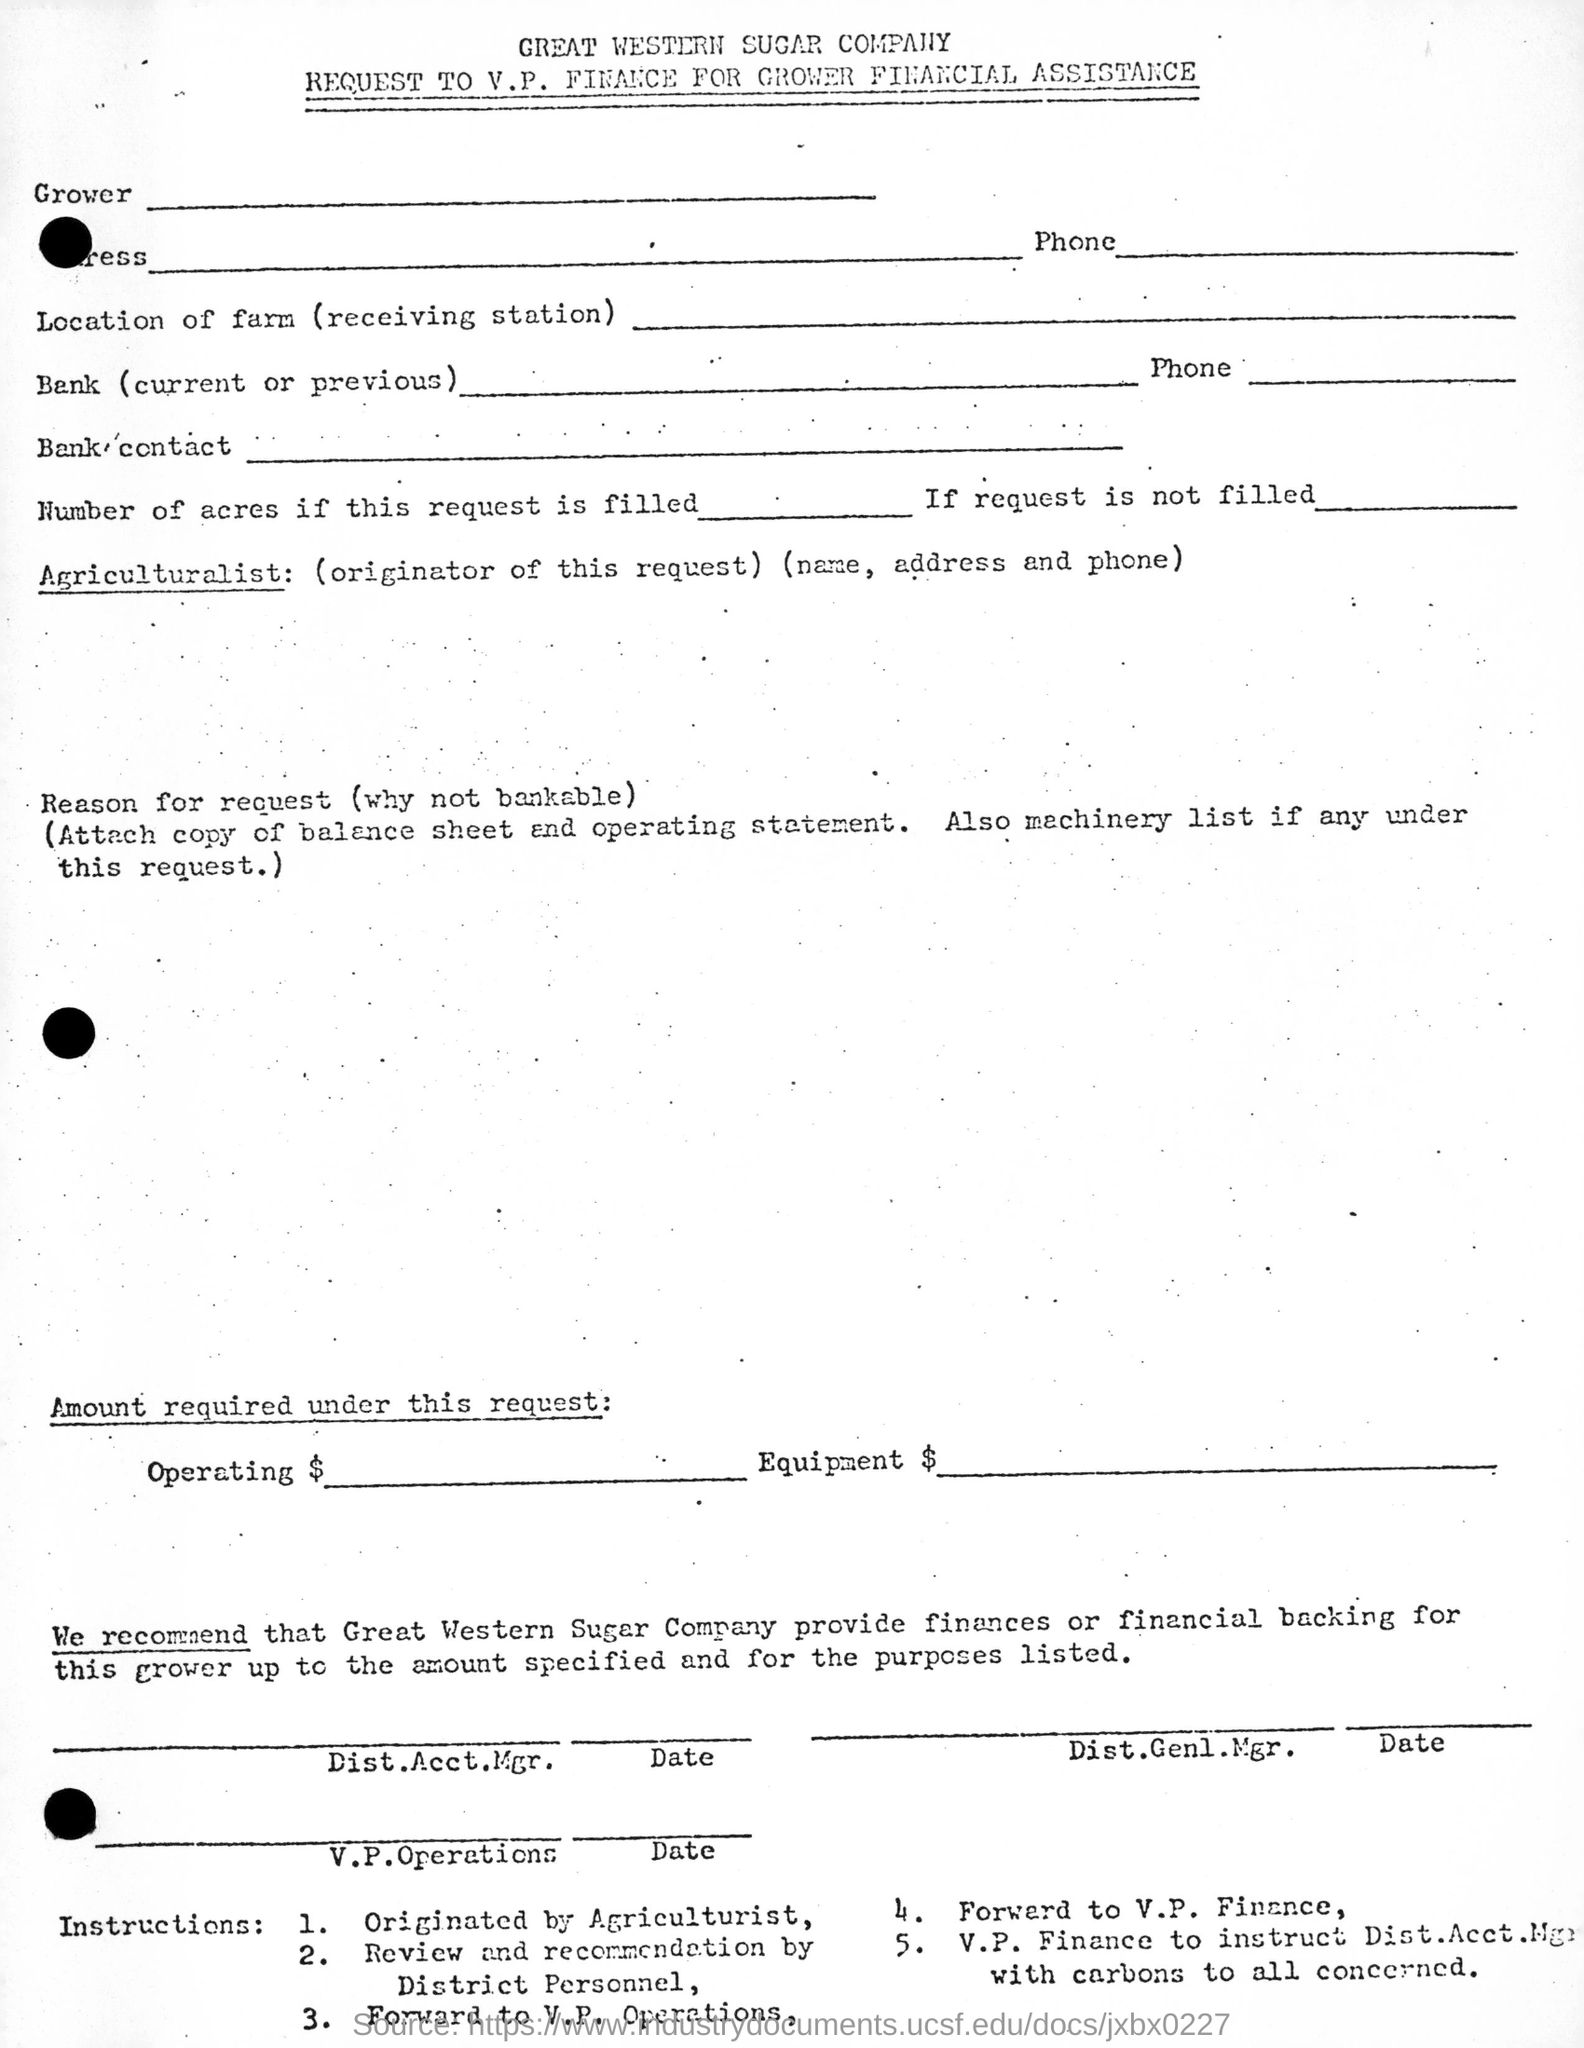Draw attention to some important aspects in this diagram. The document mentions the company GREAT WESTERN SUGAR COMPANY. 